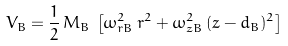Convert formula to latex. <formula><loc_0><loc_0><loc_500><loc_500>V _ { B } = \frac { 1 } { 2 } \, M _ { B } \, \left [ \omega _ { r B } ^ { 2 } \, r ^ { 2 } + \omega _ { z B } ^ { 2 } \, ( z - d _ { B } ) ^ { 2 } \right ]</formula> 